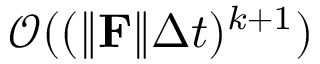<formula> <loc_0><loc_0><loc_500><loc_500>\mathcal { O } ( ( \| \mathbf F \| \Delta t ) ^ { k + 1 } )</formula> 